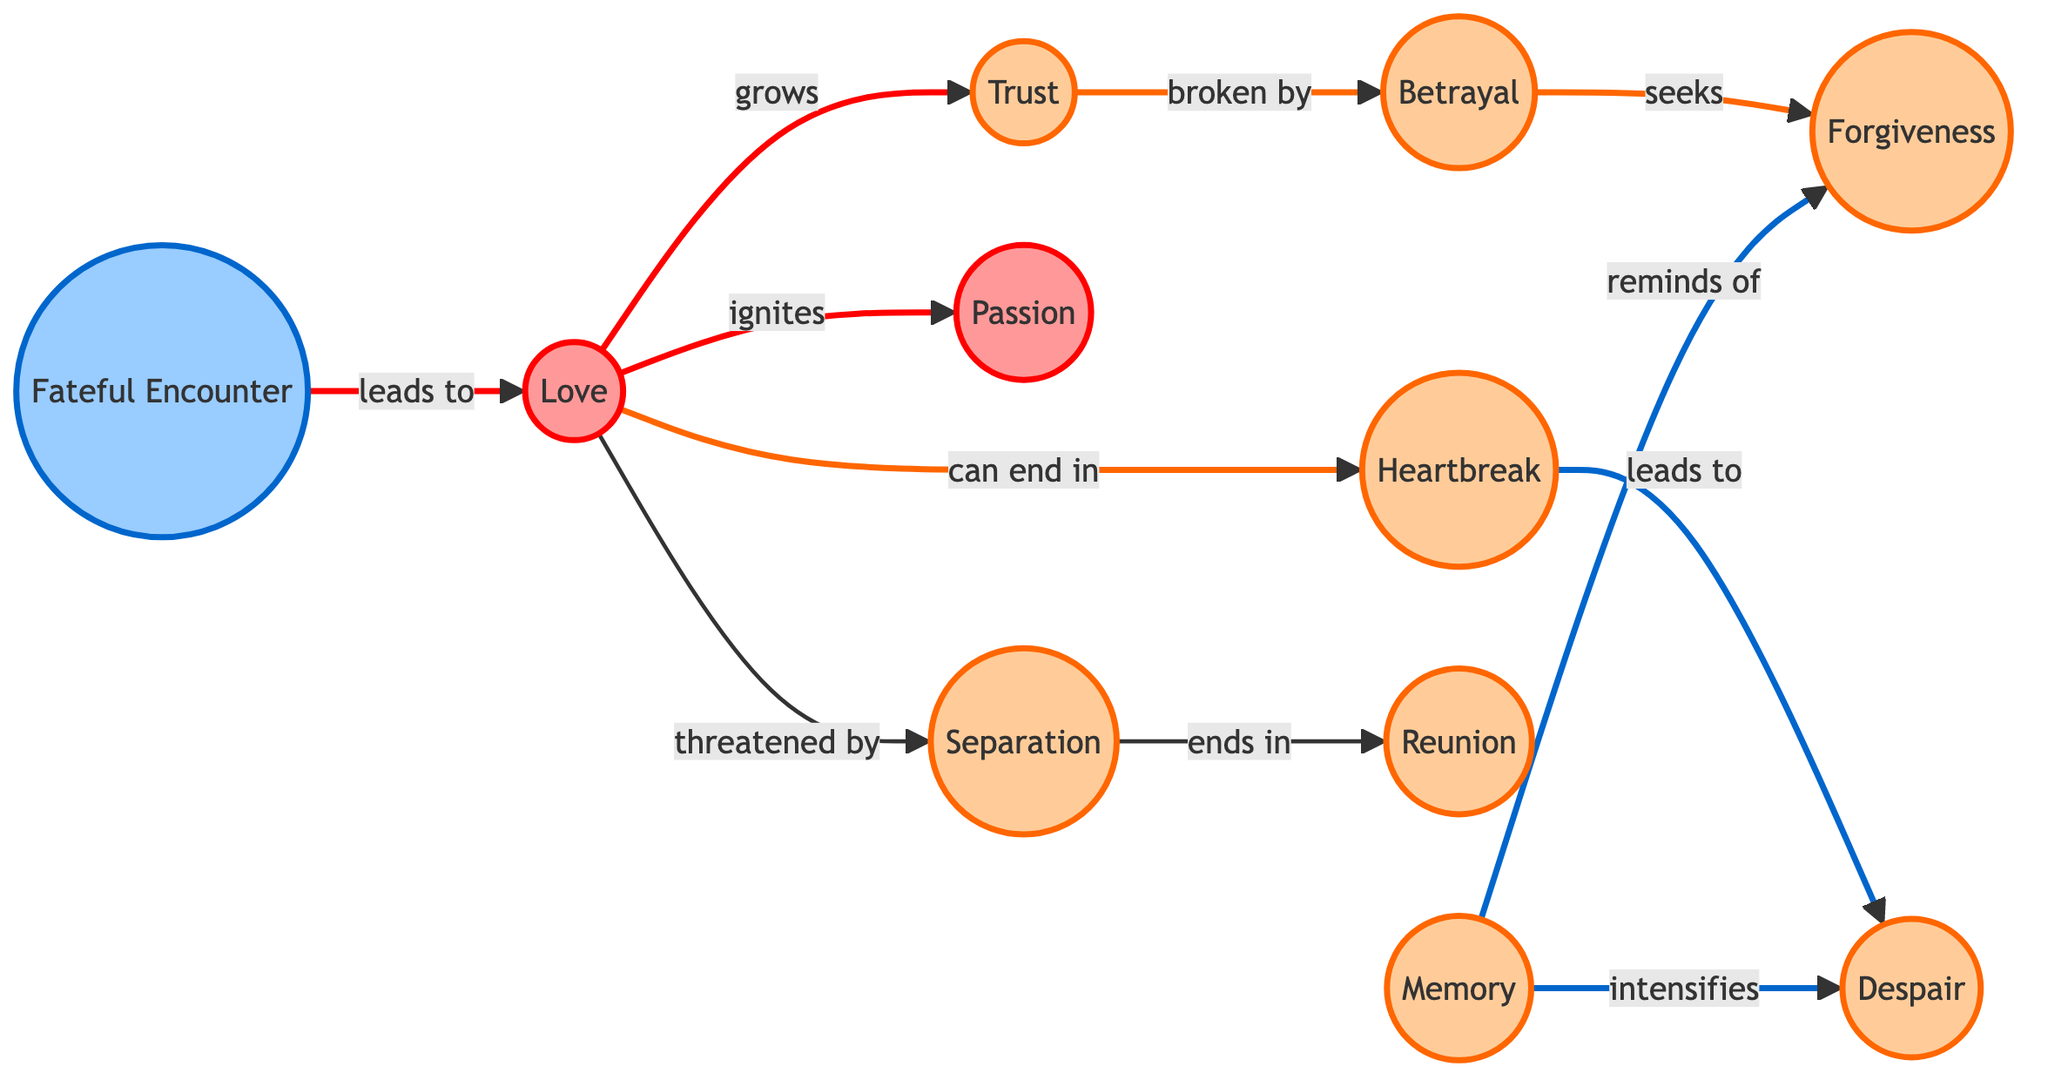What is the total number of nodes in the diagram? The diagram lists the nodes: Love, Heartbreak, Fateful Encounter, Trust, Betrayal, Passion, Reunion, Separation, Memory, Forgiveness, and Despair. Counting these, we find there are eleven nodes in total.
Answer: 11 Which emotion is directly threatened by love? The diagram indicates that love is threatened by separation, as it shows a directed edge between them labeled "threatened by."
Answer: Separation What leads to heartbreak? The diagram shows that love can end in heartbreak, as indicated by the directed edge labeled "can end in" between love and heartbreak. Therefore, heartbreak is a consequence of love.
Answer: Love How many edges are there in the diagram? By counting the connections drawn between the nodes, we find a total of ten edges connecting them, reflecting various emotional states and transformations.
Answer: 10 Which emotion intensifies due to memory? The diagram shows that memory intensifies despair, represented by the arrow labeled "intensifies" that connects memory to despair.
Answer: Despair What do betrayal and forgiveness share in the diagram? Betrayal seeks forgiveness, as indicated by the directed edge labeled "seeks" connecting betrayal to forgiveness. This shows a relationship between these two emotions in the context of the diagram.
Answer: Forgiveness What path can someone take from love to reunion in the diagram? To trace the path from love to reunion, one can follow these connections: Love → Separation (threatened by) → Reunion (ends in). This connection illustrates the flow from love through separation to reunion.
Answer: Love, Separation, Reunion What is common between fateEncounter and love? The edge labeled "leads to" from fateEncounter to love indicates that a fateful encounter leads directly to the emotion of love, suggesting a crucial turning point in the narrative.
Answer: Love What does memory remind of in the emotional journey? Memory, as indicated in the diagram, reminds of forgiveness, as shown by the direct edge connecting memory to forgiveness labeled "reminds of." This suggests a reflective process in the emotional landscape.
Answer: Forgiveness 